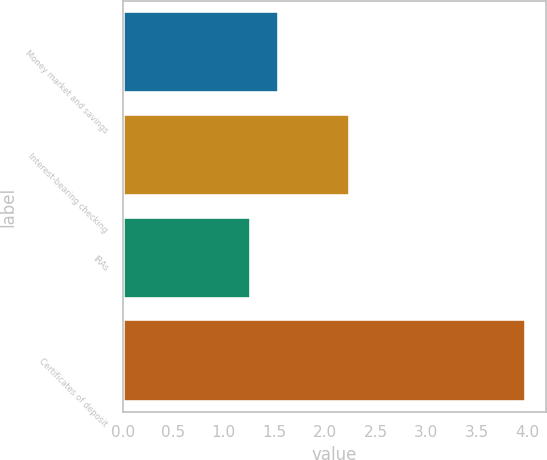<chart> <loc_0><loc_0><loc_500><loc_500><bar_chart><fcel>Money market and savings<fcel>Interest-bearing checking<fcel>IRAs<fcel>Certificates of deposit<nl><fcel>1.54<fcel>2.25<fcel>1.27<fcel>3.98<nl></chart> 